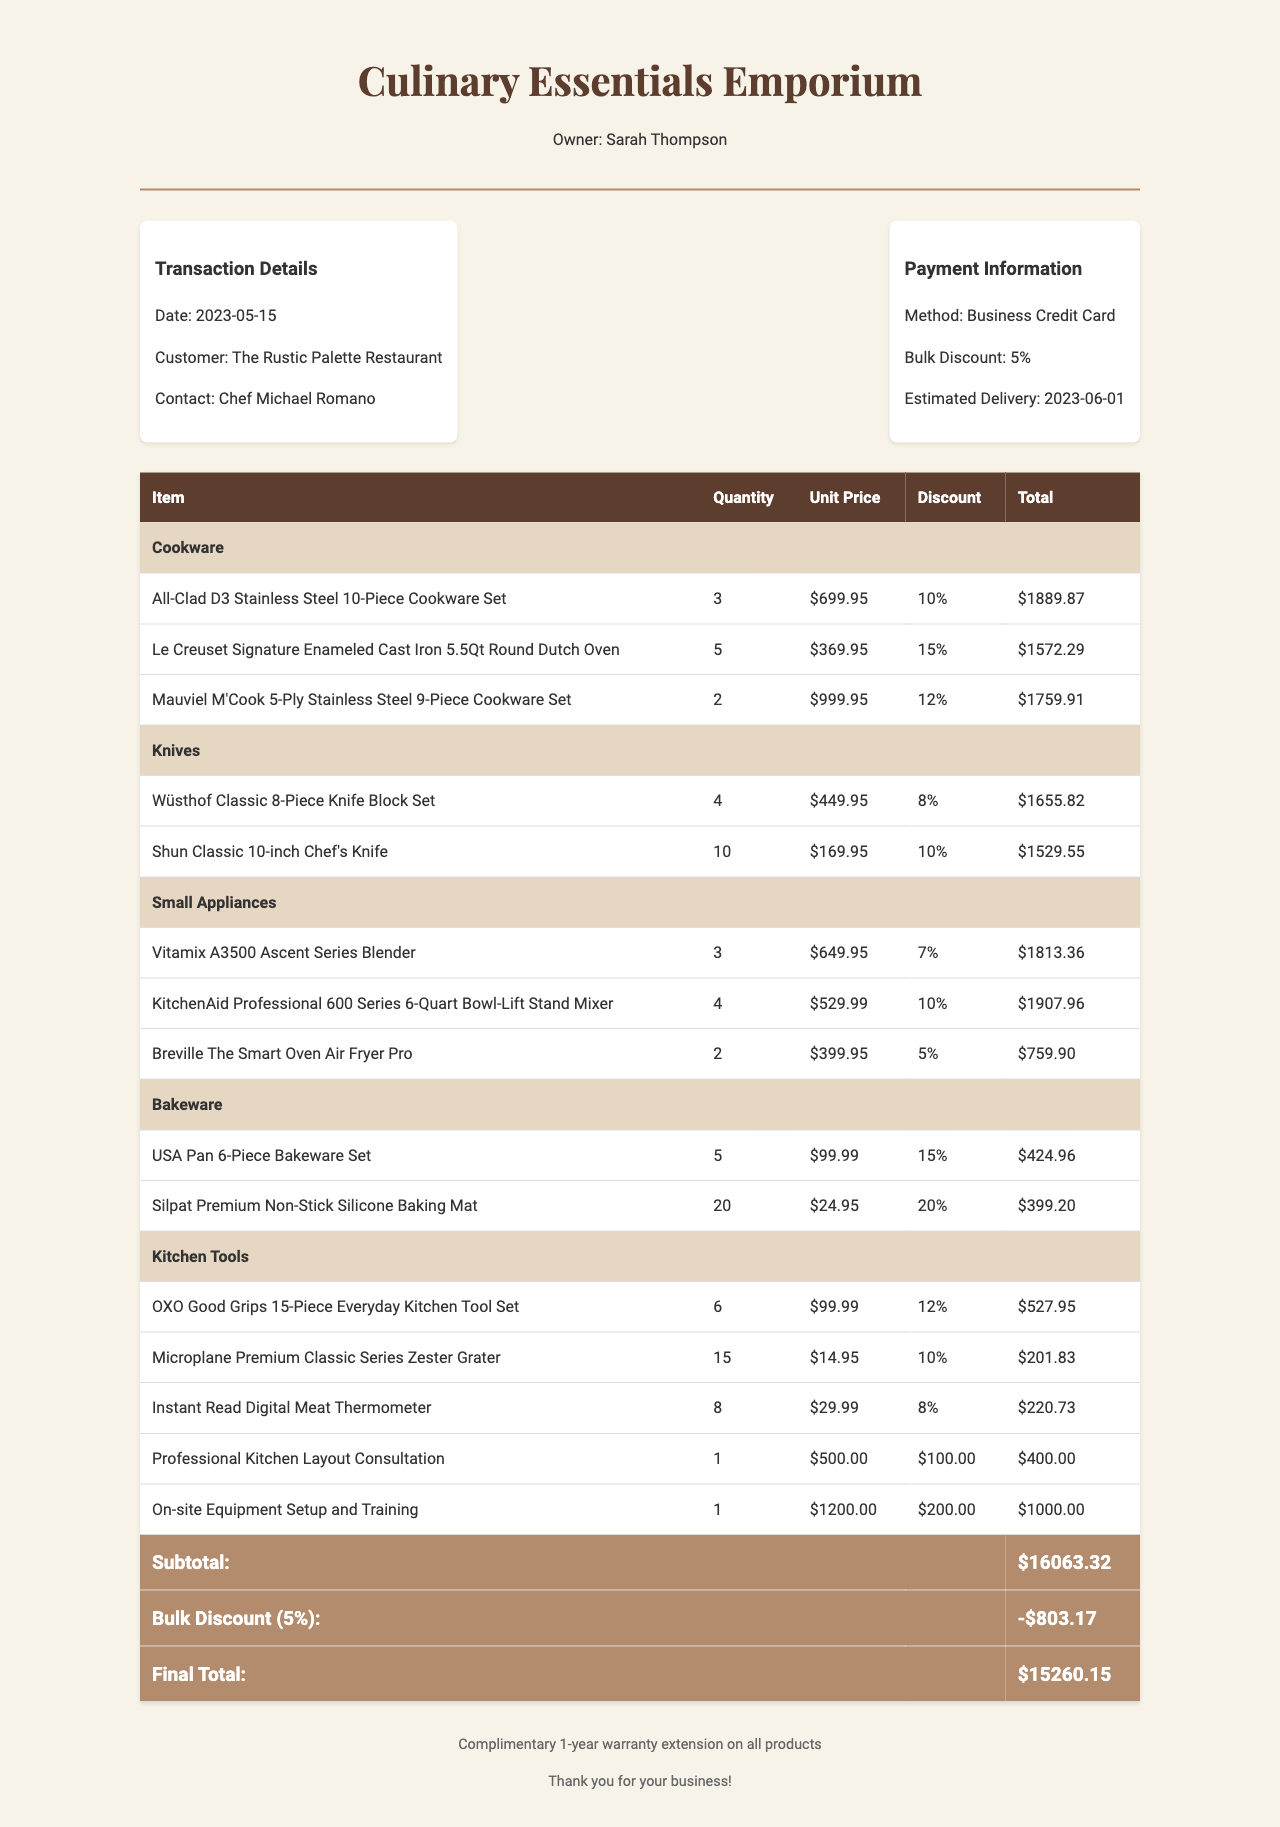What is the transaction date? The transaction date is provided in the document and is clearly stated.
Answer: 2023-05-15 Who is the customer? The customer name is specified in the document, which refers to the restaurant purchasing the items.
Answer: The Rustic Palette Restaurant What is the number of Wüsthof Classic 8-Piece Knife Block Sets purchased? The specific quantity of this product is listed in the document under the knives category.
Answer: 4 What is the total quantity of Silpat Premium Non-Stick Silicone Baking Mats ordered? The document lists the quantity for this bakeware product.
Answer: 20 What is the price of the Professional Kitchen Layout Consultation service? The price is provided directly in the section for additional services in the document.
Answer: $500.00 How much is the bulk discount percentage? The bulk discount percentage is mentioned explicitly in the payment information section.
Answer: 5% What is the final total after the bulk discount? The final total after applying the bulk discount can be calculated based on the values provided in the document.
Answer: $4,487.75 What special note accompanies the purchase? The document includes a section for special notes that inform the customer about additional benefits.
Answer: Complimentary 1-year warranty extension on all products What are the total products in the Cookware category? The total number of products in the cookware category is aggregated based on their quantities listed in the document.
Answer: 10 